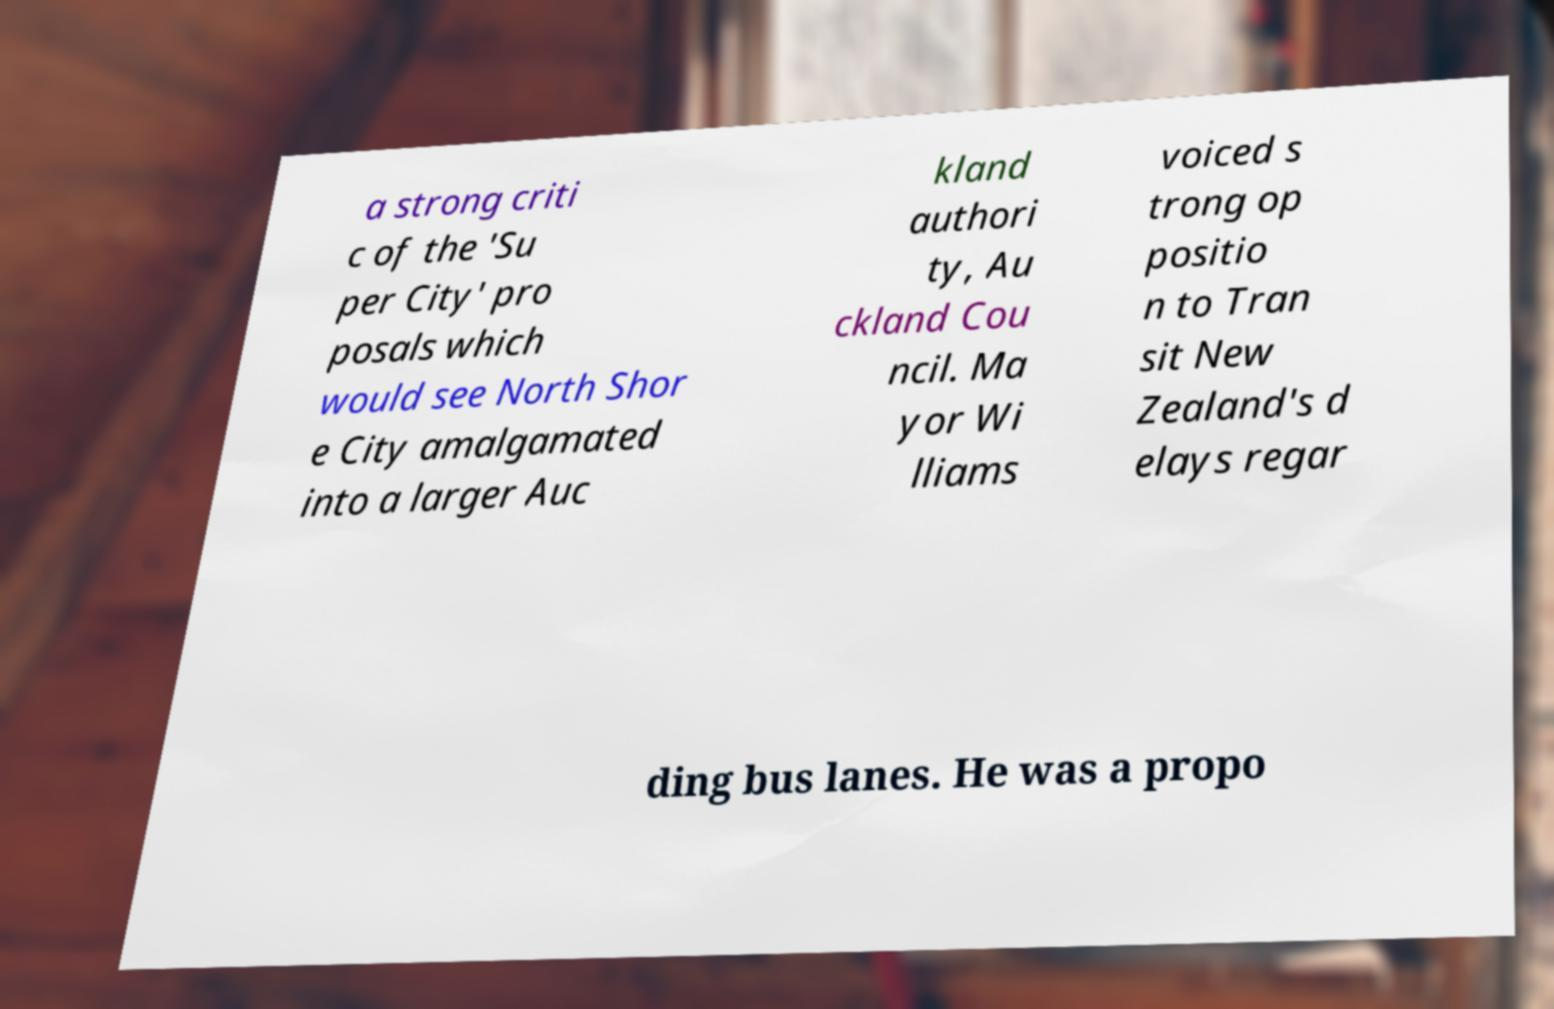Please identify and transcribe the text found in this image. a strong criti c of the 'Su per City' pro posals which would see North Shor e City amalgamated into a larger Auc kland authori ty, Au ckland Cou ncil. Ma yor Wi lliams voiced s trong op positio n to Tran sit New Zealand's d elays regar ding bus lanes. He was a propo 